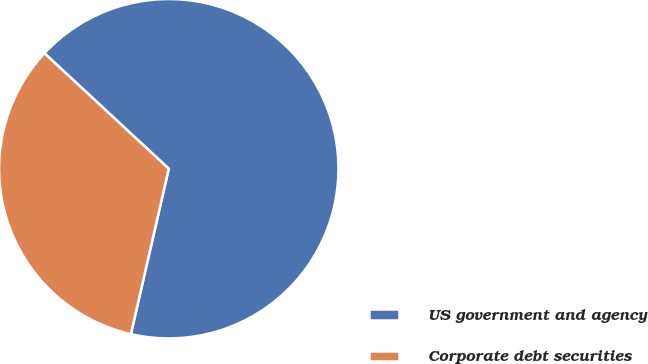Convert chart. <chart><loc_0><loc_0><loc_500><loc_500><pie_chart><fcel>US government and agency<fcel>Corporate debt securities<nl><fcel>66.67%<fcel>33.33%<nl></chart> 